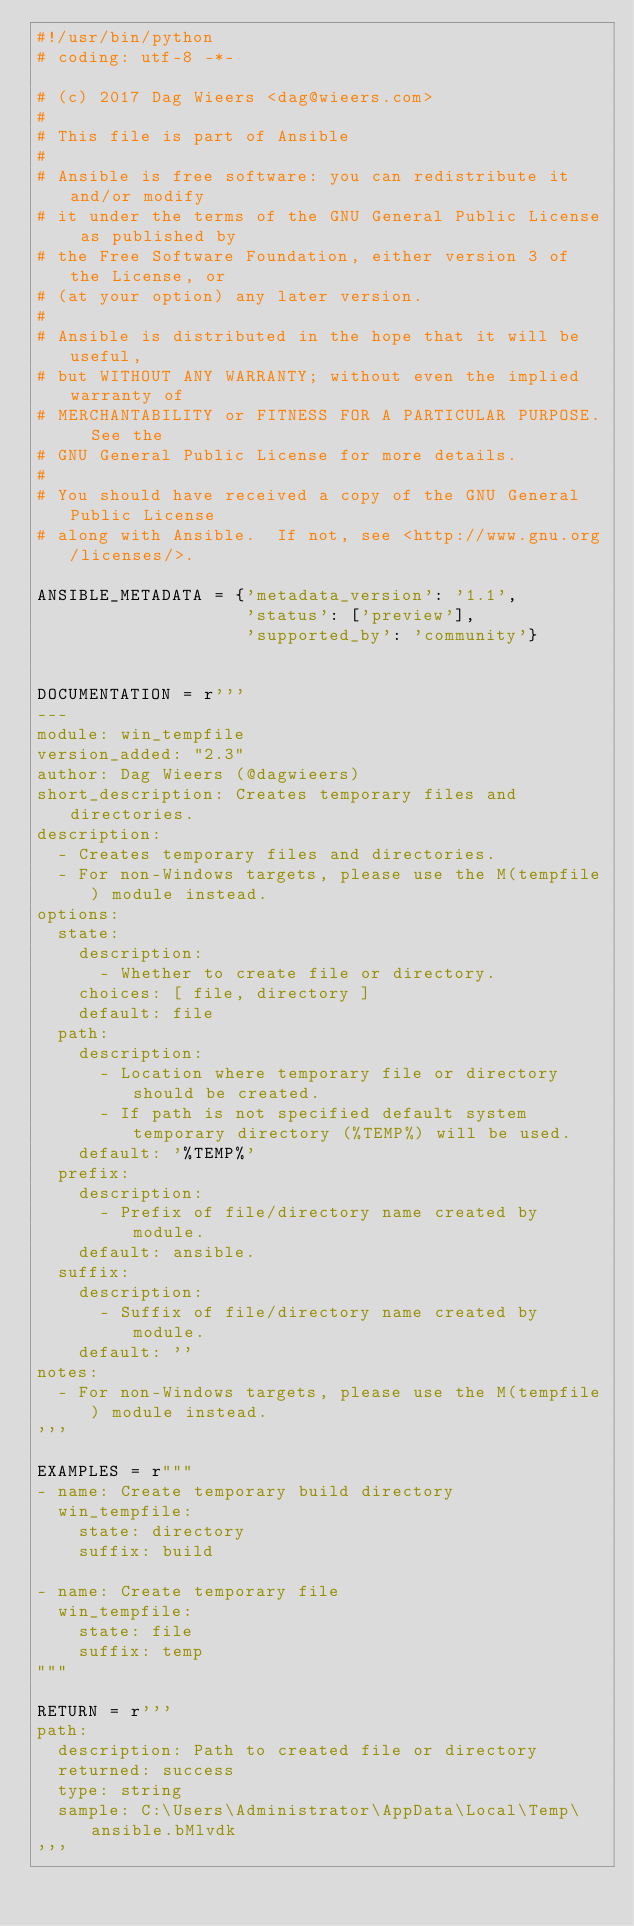Convert code to text. <code><loc_0><loc_0><loc_500><loc_500><_Python_>#!/usr/bin/python
# coding: utf-8 -*-

# (c) 2017 Dag Wieers <dag@wieers.com>
#
# This file is part of Ansible
#
# Ansible is free software: you can redistribute it and/or modify
# it under the terms of the GNU General Public License as published by
# the Free Software Foundation, either version 3 of the License, or
# (at your option) any later version.
#
# Ansible is distributed in the hope that it will be useful,
# but WITHOUT ANY WARRANTY; without even the implied warranty of
# MERCHANTABILITY or FITNESS FOR A PARTICULAR PURPOSE.  See the
# GNU General Public License for more details.
#
# You should have received a copy of the GNU General Public License
# along with Ansible.  If not, see <http://www.gnu.org/licenses/>.

ANSIBLE_METADATA = {'metadata_version': '1.1',
                    'status': ['preview'],
                    'supported_by': 'community'}


DOCUMENTATION = r'''
---
module: win_tempfile
version_added: "2.3"
author: Dag Wieers (@dagwieers)
short_description: Creates temporary files and directories.
description:
  - Creates temporary files and directories.
  - For non-Windows targets, please use the M(tempfile) module instead.
options:
  state:
    description:
      - Whether to create file or directory.
    choices: [ file, directory ]
    default: file
  path:
    description:
      - Location where temporary file or directory should be created.
      - If path is not specified default system temporary directory (%TEMP%) will be used.
    default: '%TEMP%'
  prefix:
    description:
      - Prefix of file/directory name created by module.
    default: ansible.
  suffix:
    description:
      - Suffix of file/directory name created by module.
    default: ''
notes:
  - For non-Windows targets, please use the M(tempfile) module instead.
'''

EXAMPLES = r"""
- name: Create temporary build directory
  win_tempfile:
    state: directory
    suffix: build

- name: Create temporary file
  win_tempfile:
    state: file
    suffix: temp
"""

RETURN = r'''
path:
  description: Path to created file or directory
  returned: success
  type: string
  sample: C:\Users\Administrator\AppData\Local\Temp\ansible.bMlvdk
'''
</code> 